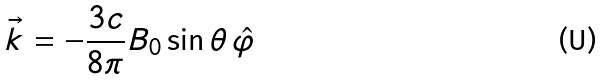<formula> <loc_0><loc_0><loc_500><loc_500>\vec { k } = - \frac { 3 c } { 8 \pi } B _ { 0 } \sin \theta \, \hat { \varphi }</formula> 